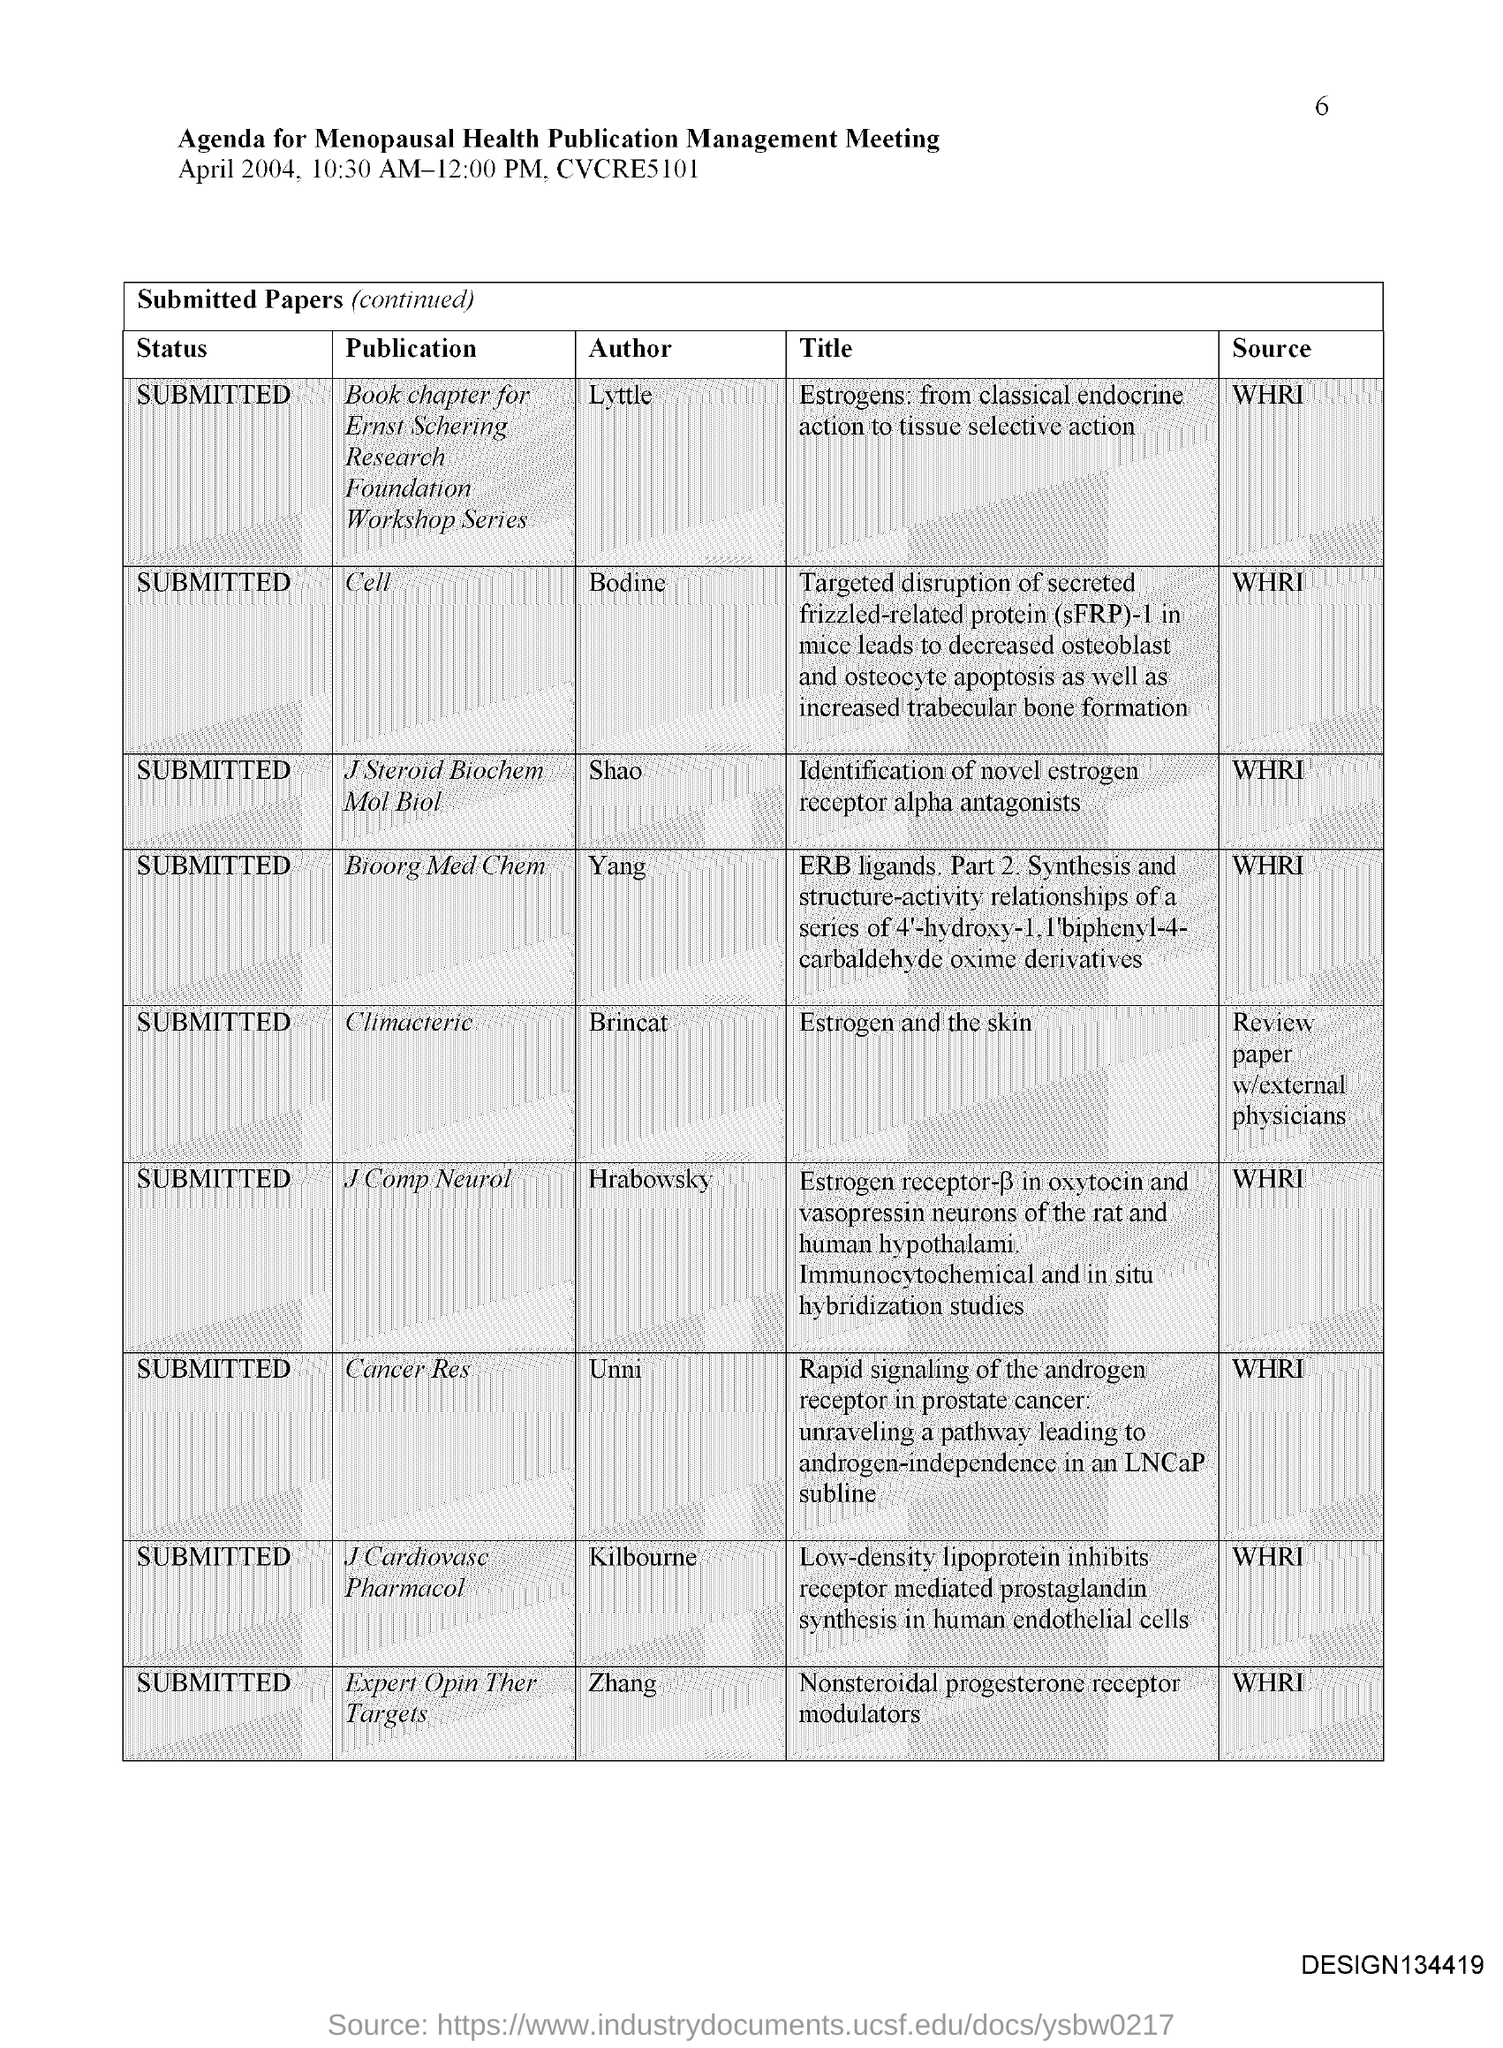Outline some significant characteristics in this image. The paper titled "Nonsteroidal progesterone receptor modulators" was authored by Zhang. The paper titled "Identification of novel estrogen receptor alpha antagonists" was authored by Shao. The paper titled "Estrogen and the skin" has been submitted. The paper titled "Identification of novel estrogen receptor alpha antagonists" was published by the WHRI (World Health Research Institute). The paper titled "Estrogens: from classical endocrine action to tissue selective action" is published by the WHRI (World Health Research Institute). 